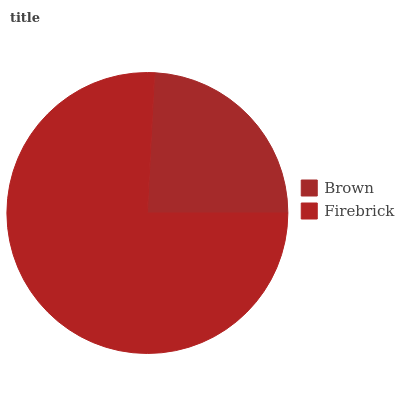Is Brown the minimum?
Answer yes or no. Yes. Is Firebrick the maximum?
Answer yes or no. Yes. Is Firebrick the minimum?
Answer yes or no. No. Is Firebrick greater than Brown?
Answer yes or no. Yes. Is Brown less than Firebrick?
Answer yes or no. Yes. Is Brown greater than Firebrick?
Answer yes or no. No. Is Firebrick less than Brown?
Answer yes or no. No. Is Firebrick the high median?
Answer yes or no. Yes. Is Brown the low median?
Answer yes or no. Yes. Is Brown the high median?
Answer yes or no. No. Is Firebrick the low median?
Answer yes or no. No. 